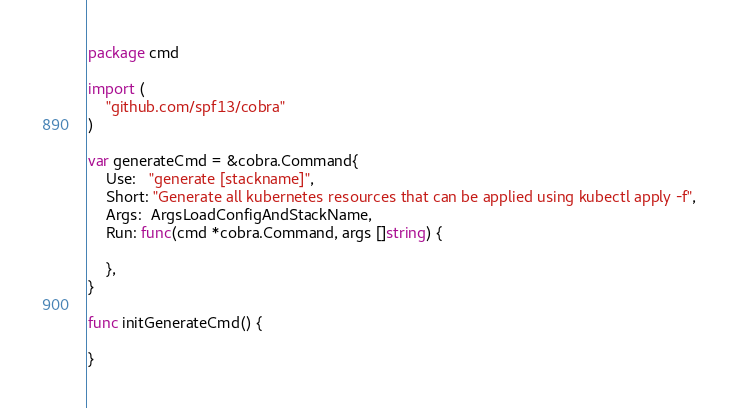Convert code to text. <code><loc_0><loc_0><loc_500><loc_500><_Go_>package cmd

import (
	"github.com/spf13/cobra"
)

var generateCmd = &cobra.Command{
	Use:   "generate [stackname]",
	Short: "Generate all kubernetes resources that can be applied using kubectl apply -f",
	Args:  ArgsLoadConfigAndStackName,
	Run: func(cmd *cobra.Command, args []string) {

	},
}

func initGenerateCmd() {

}
</code> 